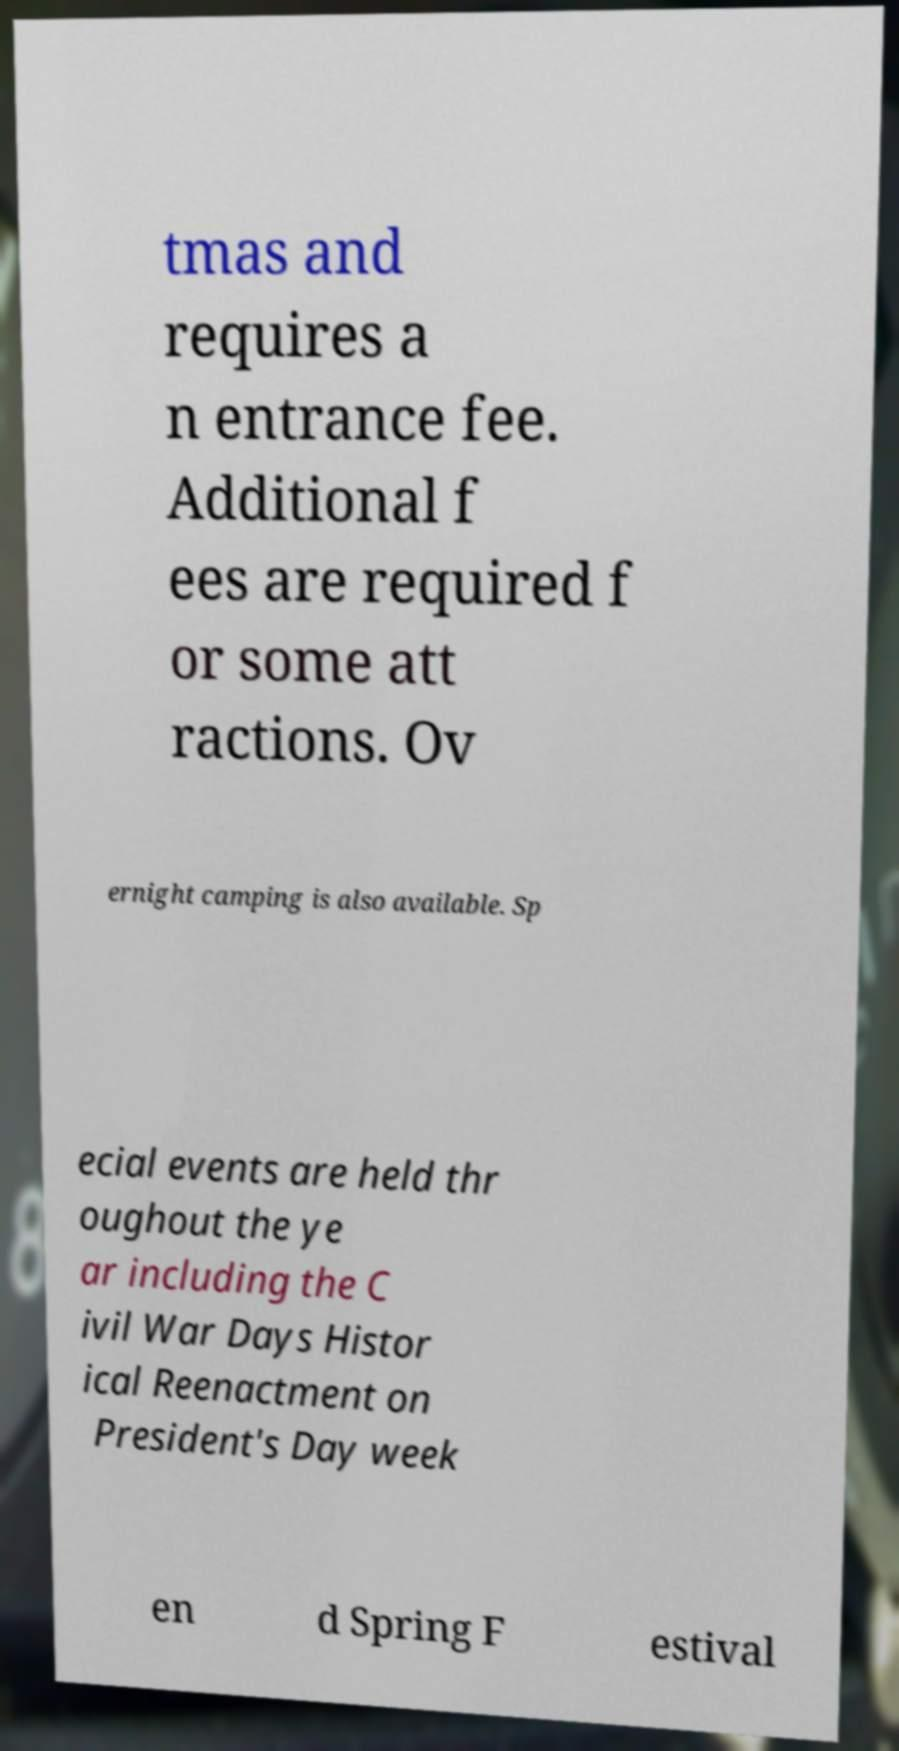Please identify and transcribe the text found in this image. tmas and requires a n entrance fee. Additional f ees are required f or some att ractions. Ov ernight camping is also available. Sp ecial events are held thr oughout the ye ar including the C ivil War Days Histor ical Reenactment on President's Day week en d Spring F estival 